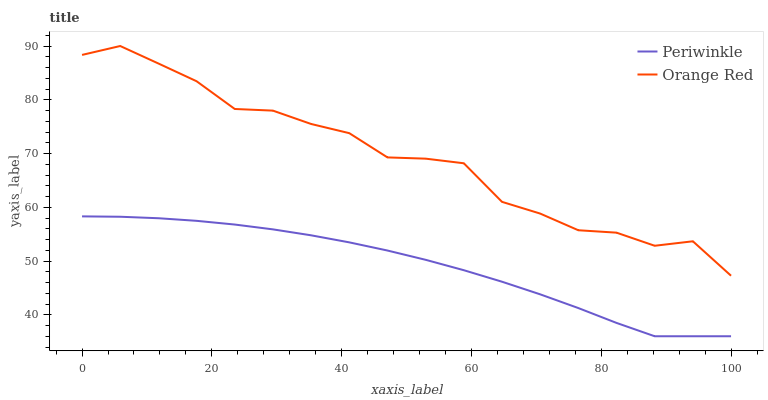Does Periwinkle have the minimum area under the curve?
Answer yes or no. Yes. Does Orange Red have the maximum area under the curve?
Answer yes or no. Yes. Does Orange Red have the minimum area under the curve?
Answer yes or no. No. Is Periwinkle the smoothest?
Answer yes or no. Yes. Is Orange Red the roughest?
Answer yes or no. Yes. Is Orange Red the smoothest?
Answer yes or no. No. Does Periwinkle have the lowest value?
Answer yes or no. Yes. Does Orange Red have the lowest value?
Answer yes or no. No. Does Orange Red have the highest value?
Answer yes or no. Yes. Is Periwinkle less than Orange Red?
Answer yes or no. Yes. Is Orange Red greater than Periwinkle?
Answer yes or no. Yes. Does Periwinkle intersect Orange Red?
Answer yes or no. No. 